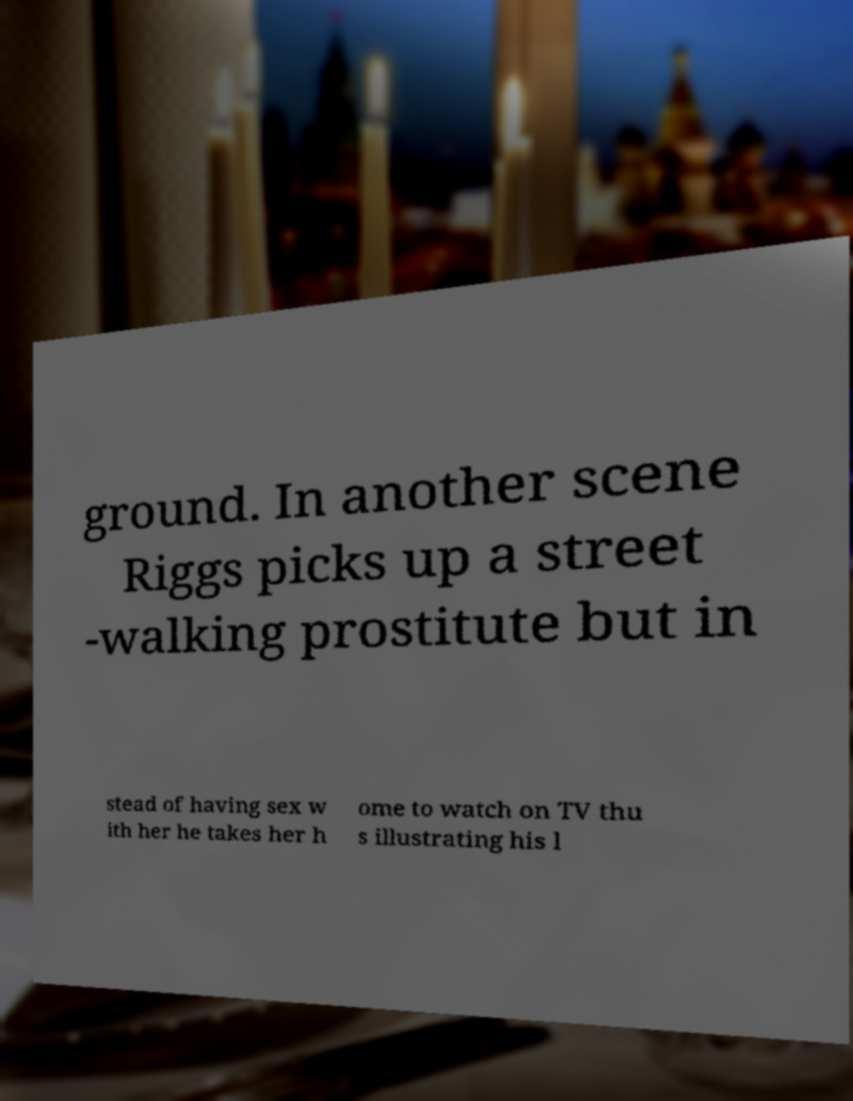What messages or text are displayed in this image? I need them in a readable, typed format. ground. In another scene Riggs picks up a street -walking prostitute but in stead of having sex w ith her he takes her h ome to watch on TV thu s illustrating his l 